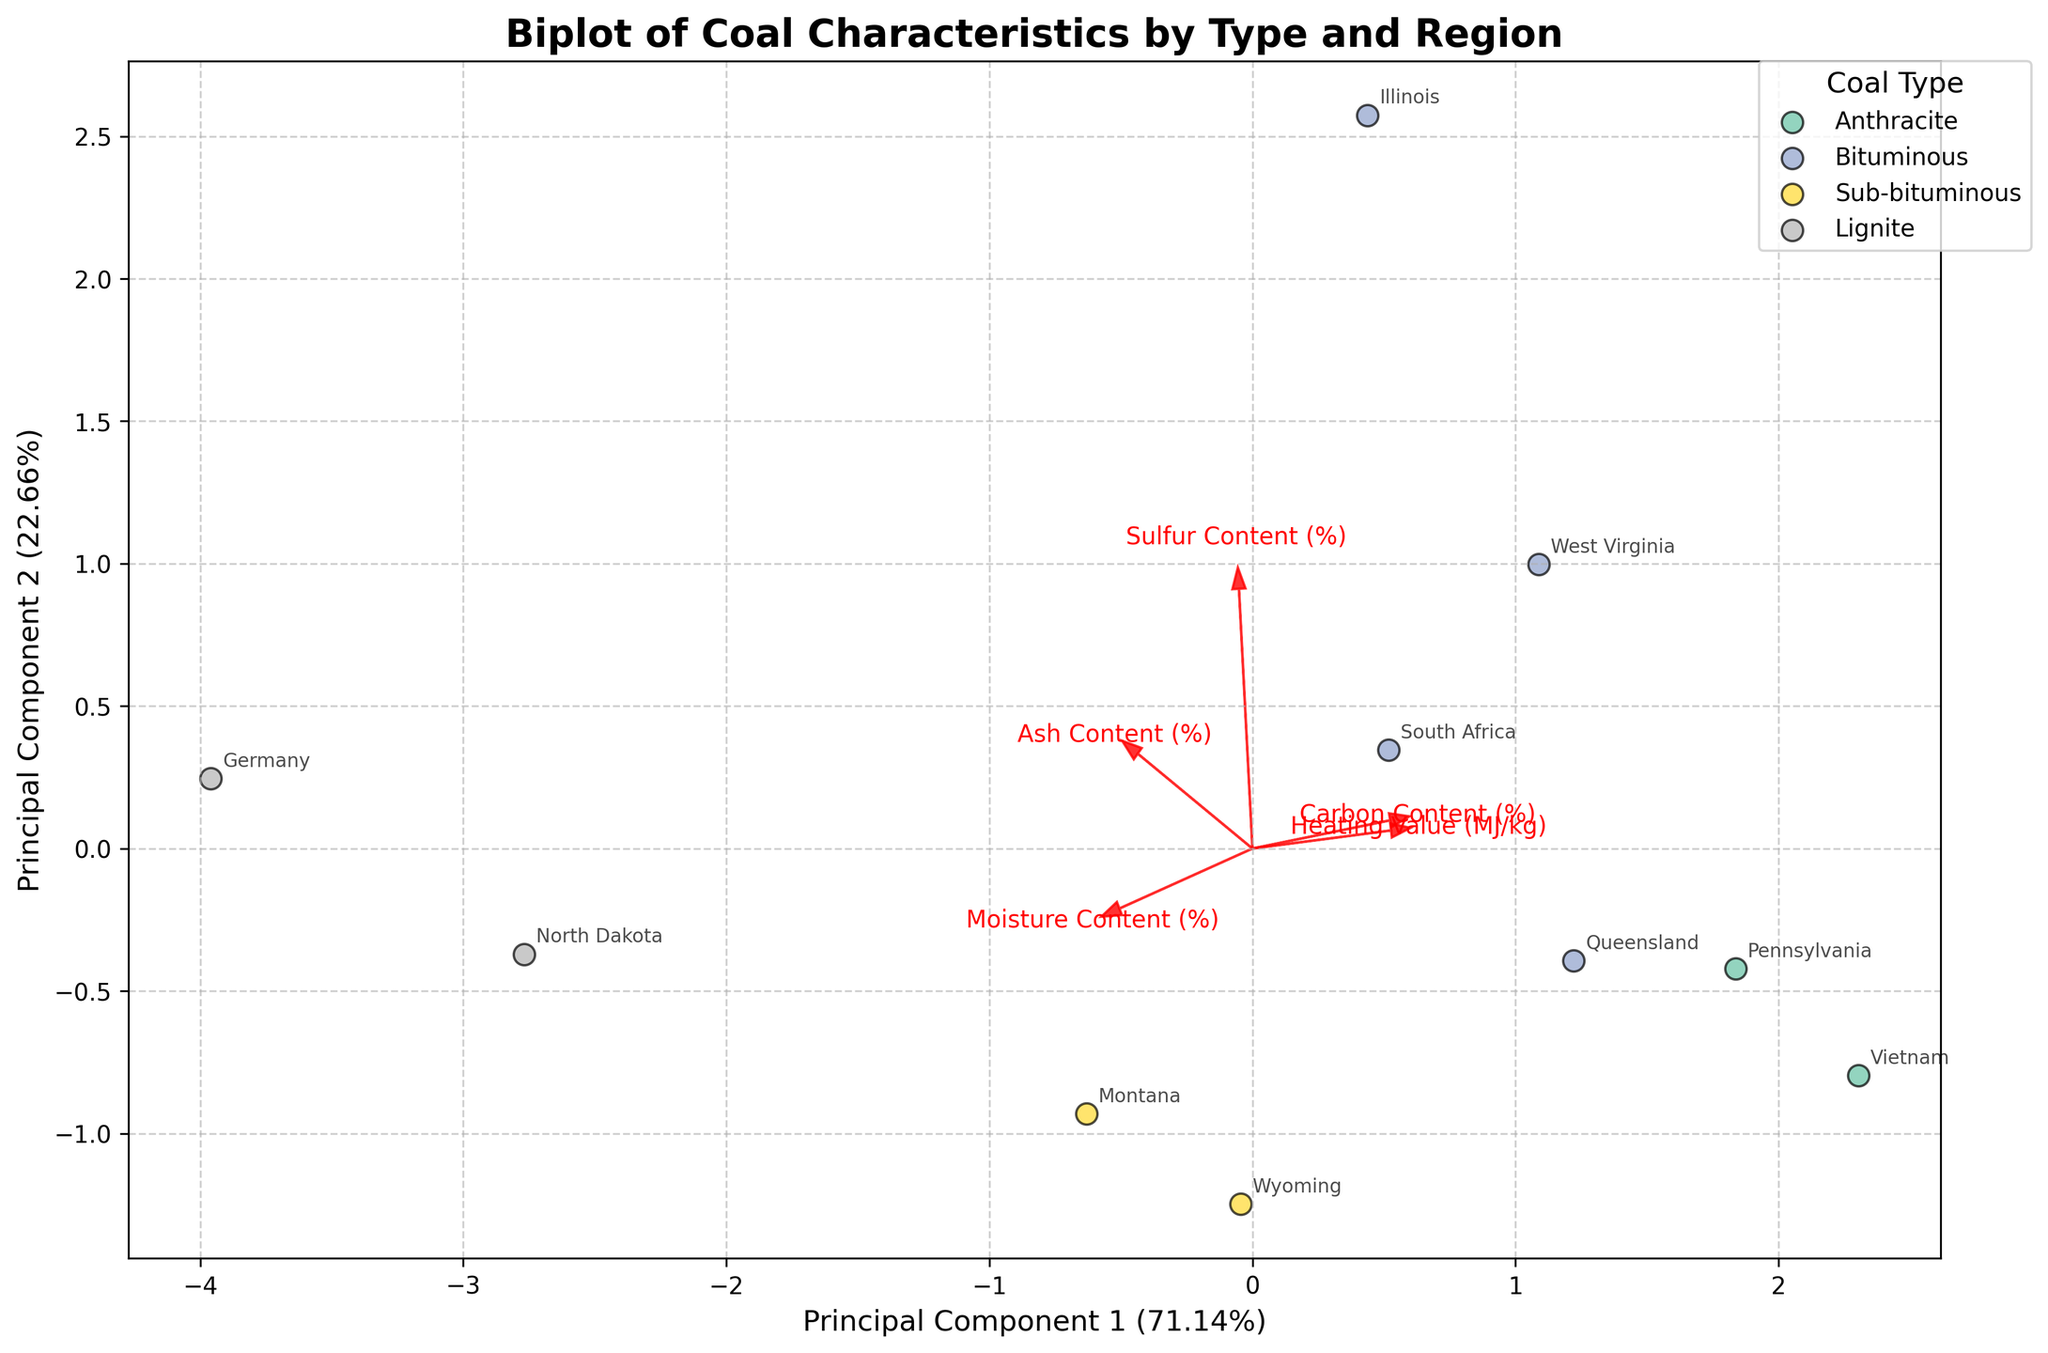What is the title of the figure? The title is displayed at the top of the figure. It provides a summary context for the visualization it represents. The title reads "Biplot of Coal Characteristics by Type and Region."
Answer: Biplot of Coal Characteristics by Type and Region How many principal components (PCs) does the biplot display? The biplot shows data along two axes labeled "Principal Component 1" and "Principal Component 2," indicating that it visualizes two principal components.
Answer: Two Which coal type has the highest contribution to Principal Component 1? By looking at the direction and length of the feature vectors, the "Carbon Content" vector aligns most closely with Principal Component 1's axis, indicating a high contribution. Therefore, the coal types with fast shifts along this axis (like Anthracite) indicate higher values.
Answer: Anthracite What percentage of the data's variance does Principal Component 2 explain? The label on the Y-axis under "Principal Component 2" specifies its explained variance ratio. The label reads something like "Principal Component 2 (35.3%)".
Answer: 35.3% Which coal type is most associated with higher heating values (MJ/kg) in the biplot? Examine the direction and magnitude of the Heating Value vector on the biplot. Anthracite (with features along this vector) aligns with higher heating values.
Answer: Anthracite Is there a clear separation between Anthracite and Lignite in the biplot? By differentiating their cluster locations, Anthracite and Lignite points are located distinctly apart in the visualization, with minimal overlap on principal components, indicating clear separation.
Answer: Yes Which regions correspond to the Anthracite coal type in the biplot? By annotating regions linked to the cluster of Anthracite points, you recognize "Pennsylvania" and "Vietnam" as the annotated labels within this cluster.
Answer: Pennsylvania and Vietnam How do carbon content and moisture content feature vectors compare in the figure? Examine the red arrows representing feature vectors. The "Carbon Content" vector is nearly opposite to the "Moisture Content" vector, suggesting a strong negative correlation between these two features in the principal component space.
Answer: They are nearly opposite in direction Which coal type and region correspond to the highest moisture content? Identify the arrow for "Moisture Content" and look for a cluster of points in the direction of that arrow. The points are near the upper region labeled "North Dakota," where Lignite is extracted.
Answer: Lignite, North Dakota What can be inferred about the relationship between Sulfur Content and Heating Value from the biplot? Inspect the angles between the Sulfur Content and Heating Value vectors. If these vectors are almost perpendicular, it signifies little to no correlation between these two variables in the dataset.
Answer: There is little to no correlation 